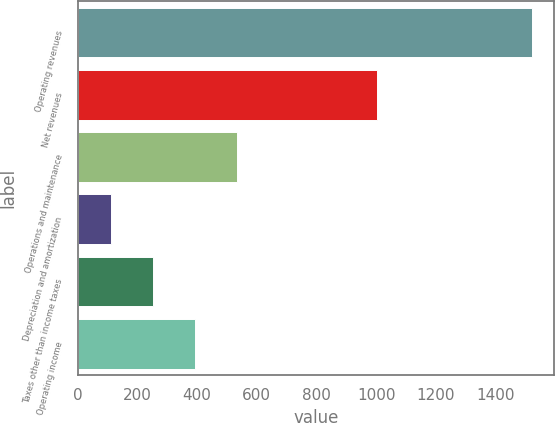Convert chart. <chart><loc_0><loc_0><loc_500><loc_500><bar_chart><fcel>Operating revenues<fcel>Net revenues<fcel>Operations and maintenance<fcel>Depreciation and amortization<fcel>Taxes other than income taxes<fcel>Operating income<nl><fcel>1521<fcel>1003<fcel>533.3<fcel>110<fcel>251.1<fcel>392.2<nl></chart> 